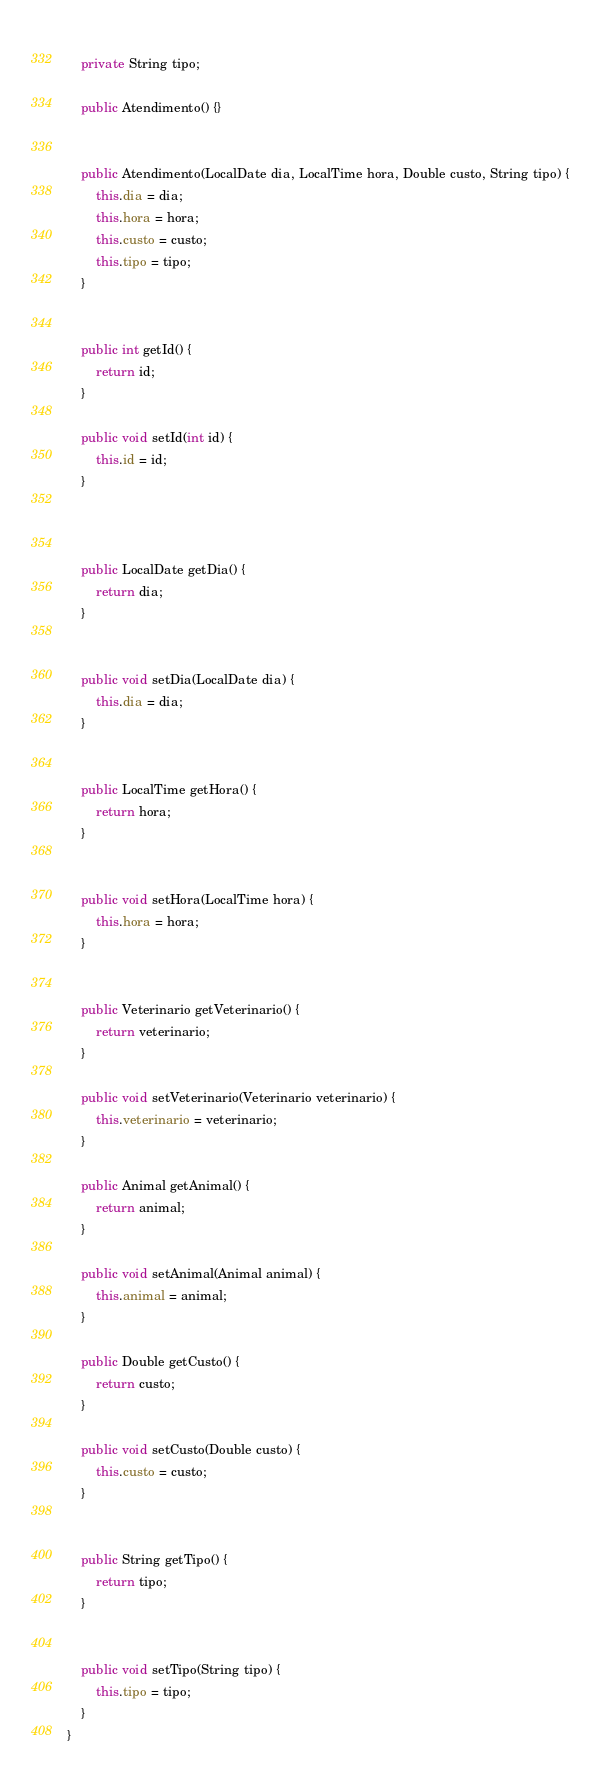<code> <loc_0><loc_0><loc_500><loc_500><_Java_>	
	private String tipo;

	public Atendimento() {}
	
	
	public Atendimento(LocalDate dia, LocalTime hora, Double custo, String tipo) {
		this.dia = dia;
		this.hora = hora;
		this.custo = custo;
		this.tipo = tipo;
	}


	public int getId() {
		return id;
	}

	public void setId(int id) {
		this.id = id;
	}

	

	public LocalDate getDia() {
		return dia;
	}


	public void setDia(LocalDate dia) {
		this.dia = dia;
	}


	public LocalTime getHora() {
		return hora;
	}


	public void setHora(LocalTime hora) {
		this.hora = hora;
	}


	public Veterinario getVeterinario() {
		return veterinario;
	}

	public void setVeterinario(Veterinario veterinario) {
		this.veterinario = veterinario;
	}

	public Animal getAnimal() {
		return animal;
	}

	public void setAnimal(Animal animal) {
		this.animal = animal;
	}

	public Double getCusto() {
		return custo;
	}

	public void setCusto(Double custo) {
		this.custo = custo;
	}


	public String getTipo() {
		return tipo;
	}


	public void setTipo(String tipo) {
		this.tipo = tipo;
	}
}
</code> 